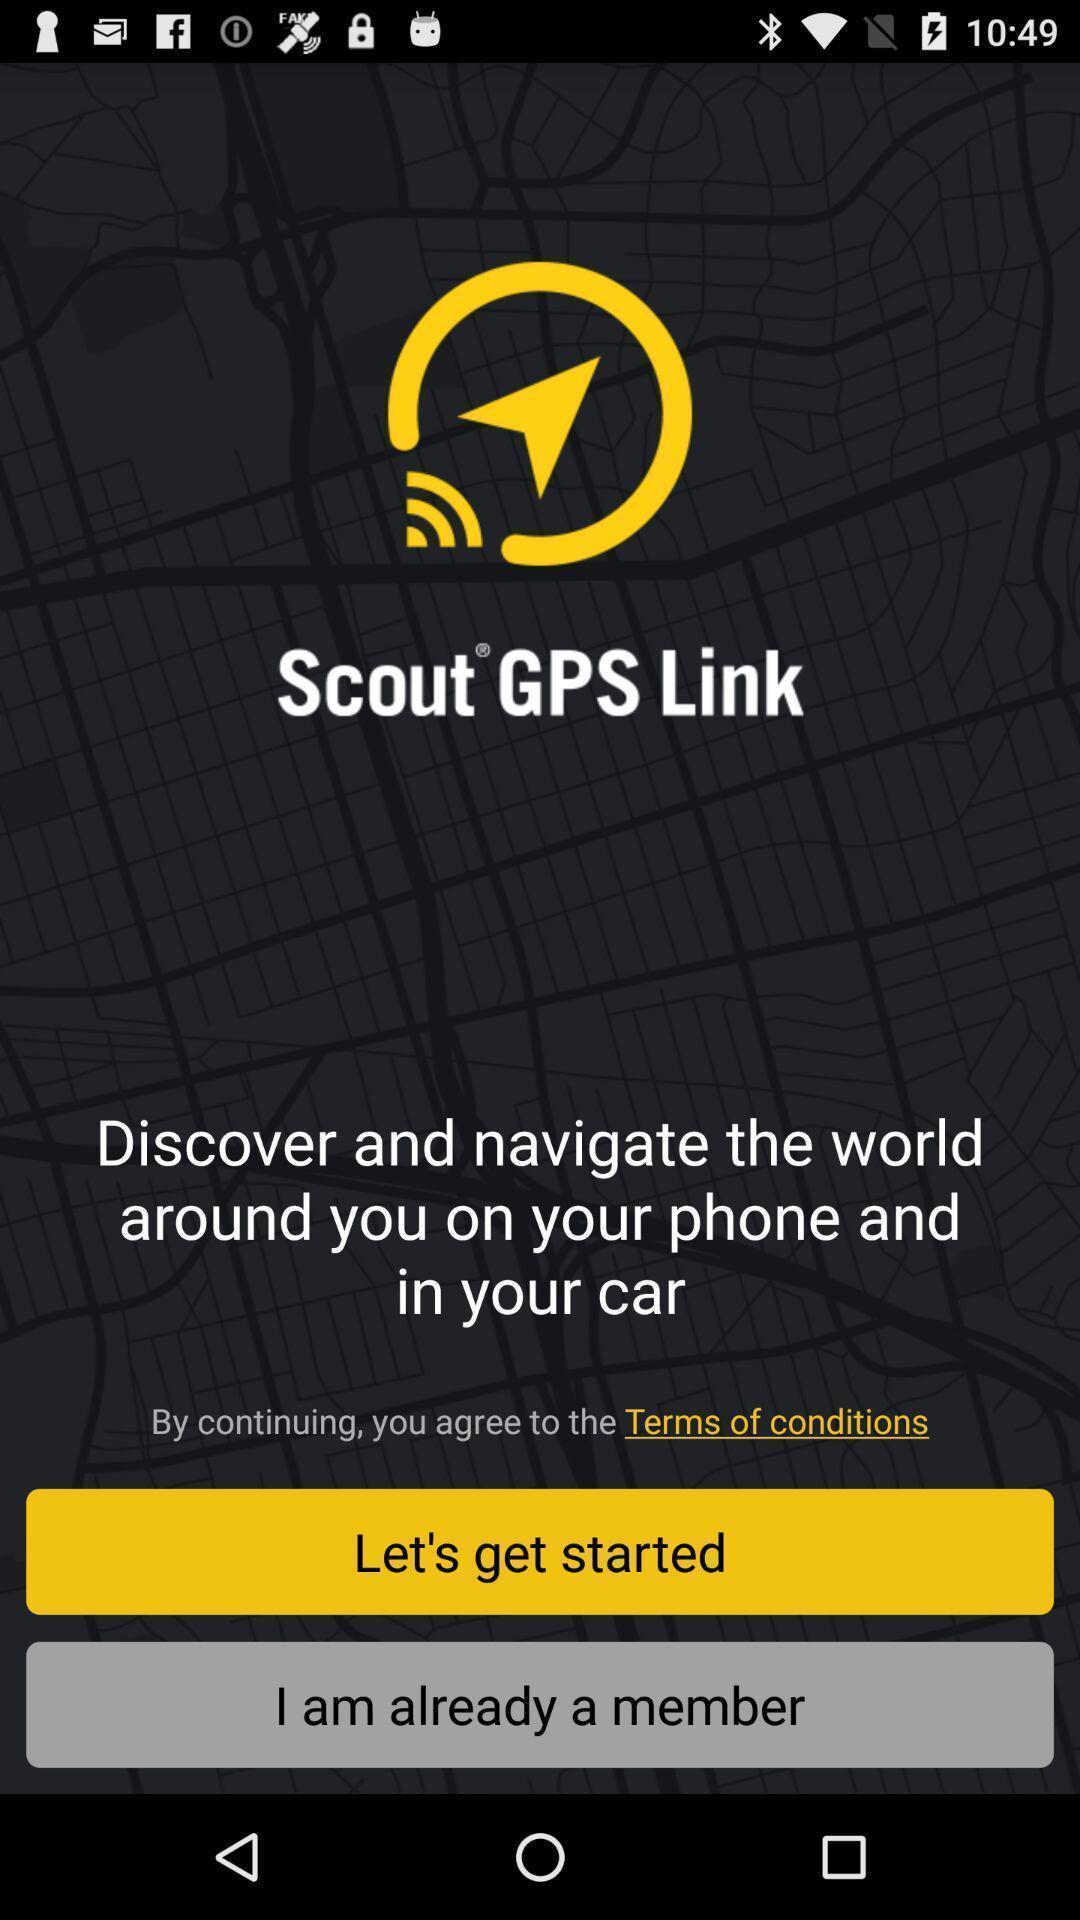Explain what's happening in this screen capture. Welcome page of a social app. 